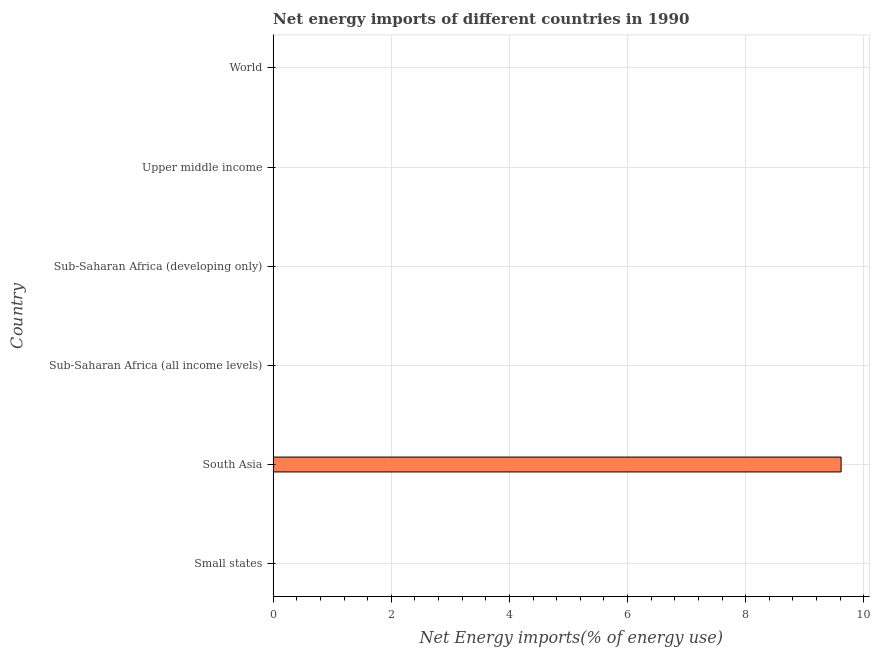Does the graph contain any zero values?
Offer a terse response. Yes. Does the graph contain grids?
Your answer should be very brief. Yes. What is the title of the graph?
Offer a terse response. Net energy imports of different countries in 1990. What is the label or title of the X-axis?
Provide a short and direct response. Net Energy imports(% of energy use). What is the label or title of the Y-axis?
Your answer should be compact. Country. What is the energy imports in Sub-Saharan Africa (developing only)?
Provide a succinct answer. 0. Across all countries, what is the maximum energy imports?
Keep it short and to the point. 9.62. In which country was the energy imports maximum?
Give a very brief answer. South Asia. What is the sum of the energy imports?
Offer a very short reply. 9.62. What is the average energy imports per country?
Give a very brief answer. 1.6. What is the difference between the highest and the lowest energy imports?
Ensure brevity in your answer.  9.62. In how many countries, is the energy imports greater than the average energy imports taken over all countries?
Ensure brevity in your answer.  1. How many bars are there?
Your answer should be compact. 1. How many countries are there in the graph?
Provide a succinct answer. 6. What is the Net Energy imports(% of energy use) of South Asia?
Ensure brevity in your answer.  9.62. What is the Net Energy imports(% of energy use) of Sub-Saharan Africa (all income levels)?
Provide a succinct answer. 0. What is the Net Energy imports(% of energy use) of Sub-Saharan Africa (developing only)?
Offer a very short reply. 0. What is the Net Energy imports(% of energy use) in World?
Give a very brief answer. 0. 